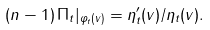Convert formula to latex. <formula><loc_0><loc_0><loc_500><loc_500>( n - 1 ) \, \Pi _ { t } | _ { \varphi _ { t } ( v ) } = \eta _ { t } ^ { \prime } ( v ) / \eta _ { t } ( v ) .</formula> 